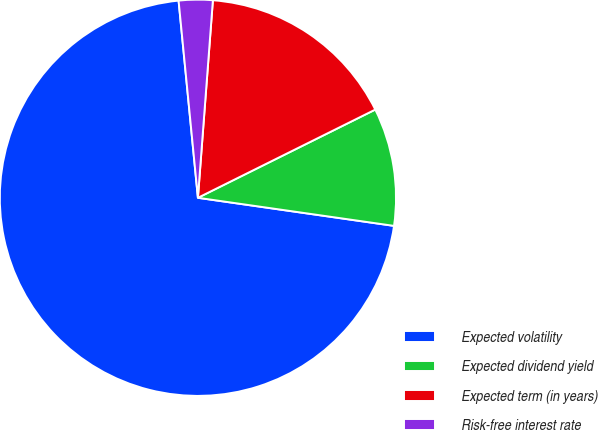Convert chart to OTSL. <chart><loc_0><loc_0><loc_500><loc_500><pie_chart><fcel>Expected volatility<fcel>Expected dividend yield<fcel>Expected term (in years)<fcel>Risk-free interest rate<nl><fcel>71.18%<fcel>9.61%<fcel>16.45%<fcel>2.76%<nl></chart> 